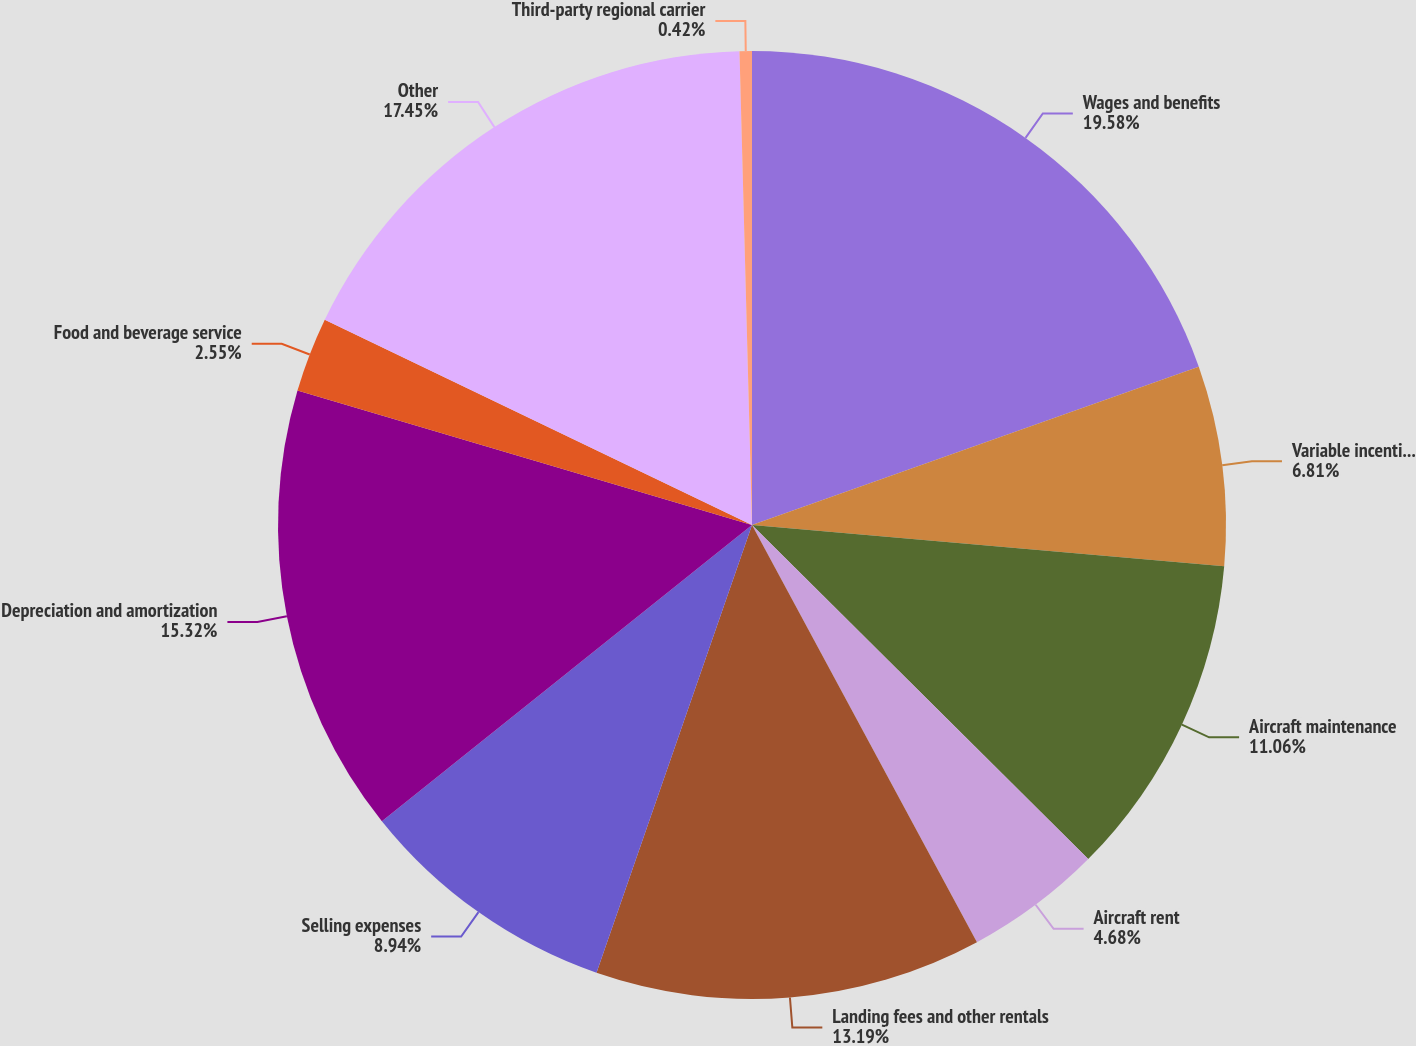Convert chart. <chart><loc_0><loc_0><loc_500><loc_500><pie_chart><fcel>Wages and benefits<fcel>Variable incentive pay<fcel>Aircraft maintenance<fcel>Aircraft rent<fcel>Landing fees and other rentals<fcel>Selling expenses<fcel>Depreciation and amortization<fcel>Food and beverage service<fcel>Other<fcel>Third-party regional carrier<nl><fcel>19.58%<fcel>6.81%<fcel>11.06%<fcel>4.68%<fcel>13.19%<fcel>8.94%<fcel>15.32%<fcel>2.55%<fcel>17.45%<fcel>0.42%<nl></chart> 